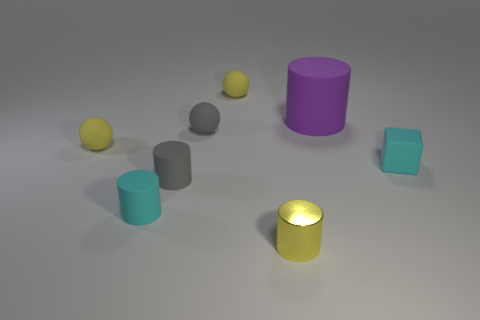Add 1 tiny yellow metal objects. How many objects exist? 9 Subtract all blocks. How many objects are left? 7 Add 2 small things. How many small things exist? 9 Subtract 2 yellow spheres. How many objects are left? 6 Subtract all cyan rubber cubes. Subtract all purple cylinders. How many objects are left? 6 Add 8 yellow cylinders. How many yellow cylinders are left? 9 